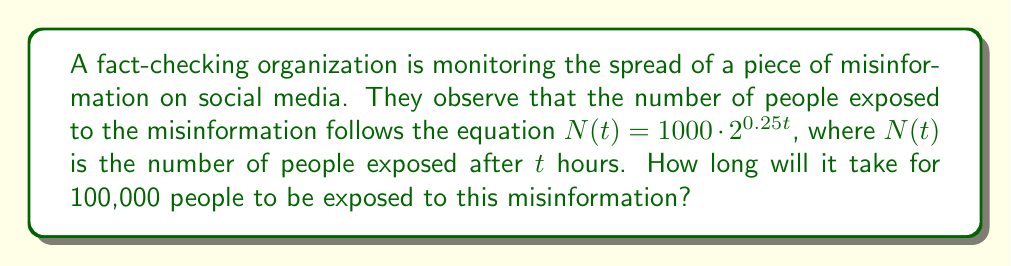Could you help me with this problem? To solve this problem, we'll use the given logarithmic equation and follow these steps:

1) We're given the equation: $N(t) = 1000 \cdot 2^{0.25t}$

2) We want to find $t$ when $N(t) = 100,000$. So, let's set up the equation:

   $100,000 = 1000 \cdot 2^{0.25t}$

3) Divide both sides by 1000:

   $100 = 2^{0.25t}$

4) Now, we can apply the logarithm (base 2) to both sides:

   $\log_2(100) = \log_2(2^{0.25t})$

5) Using the logarithm property $\log_a(a^x) = x$, we get:

   $\log_2(100) = 0.25t$

6) Solve for $t$:

   $t = \frac{\log_2(100)}{0.25}$

7) Calculate $\log_2(100)$:
   
   $\log_2(100) = \frac{\log(100)}{\log(2)} \approx 6.6439$

8) Finally, calculate $t$:

   $t = \frac{6.6439}{0.25} \approx 26.5756$

Therefore, it will take approximately 26.58 hours for 100,000 people to be exposed to the misinformation.
Answer: 26.58 hours 